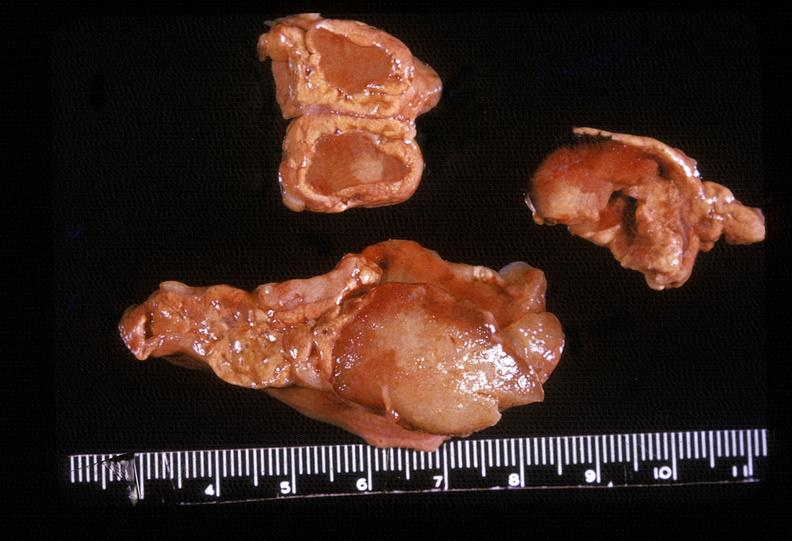s coronary artery anomalous origin left from pulmonary artery present?
Answer the question using a single word or phrase. No 